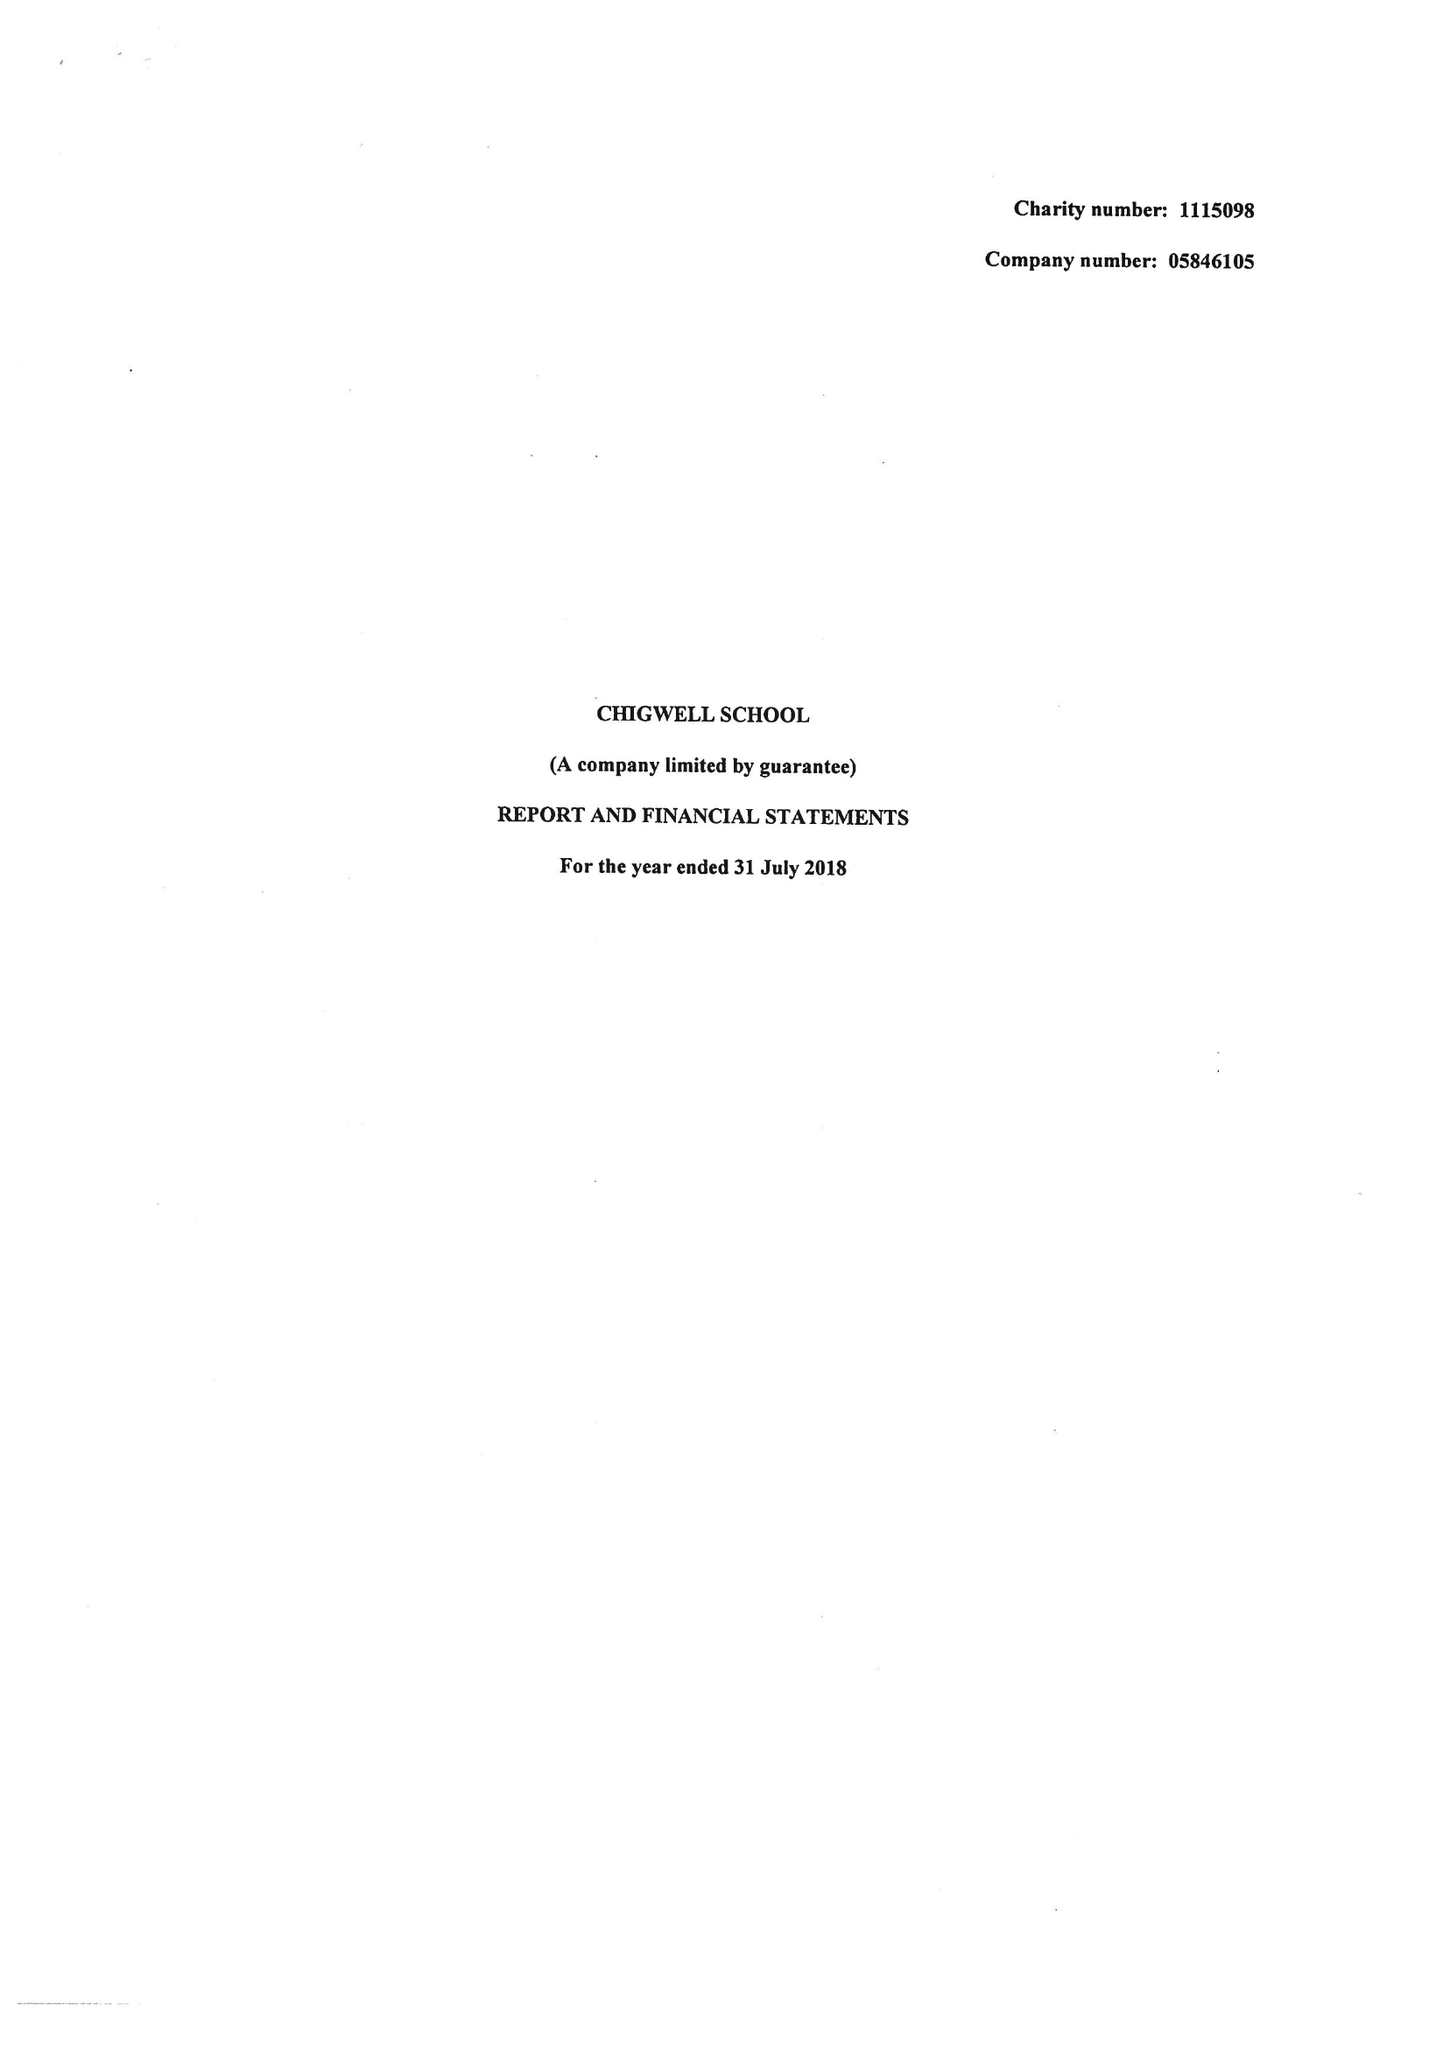What is the value for the report_date?
Answer the question using a single word or phrase. 2018-07-31 